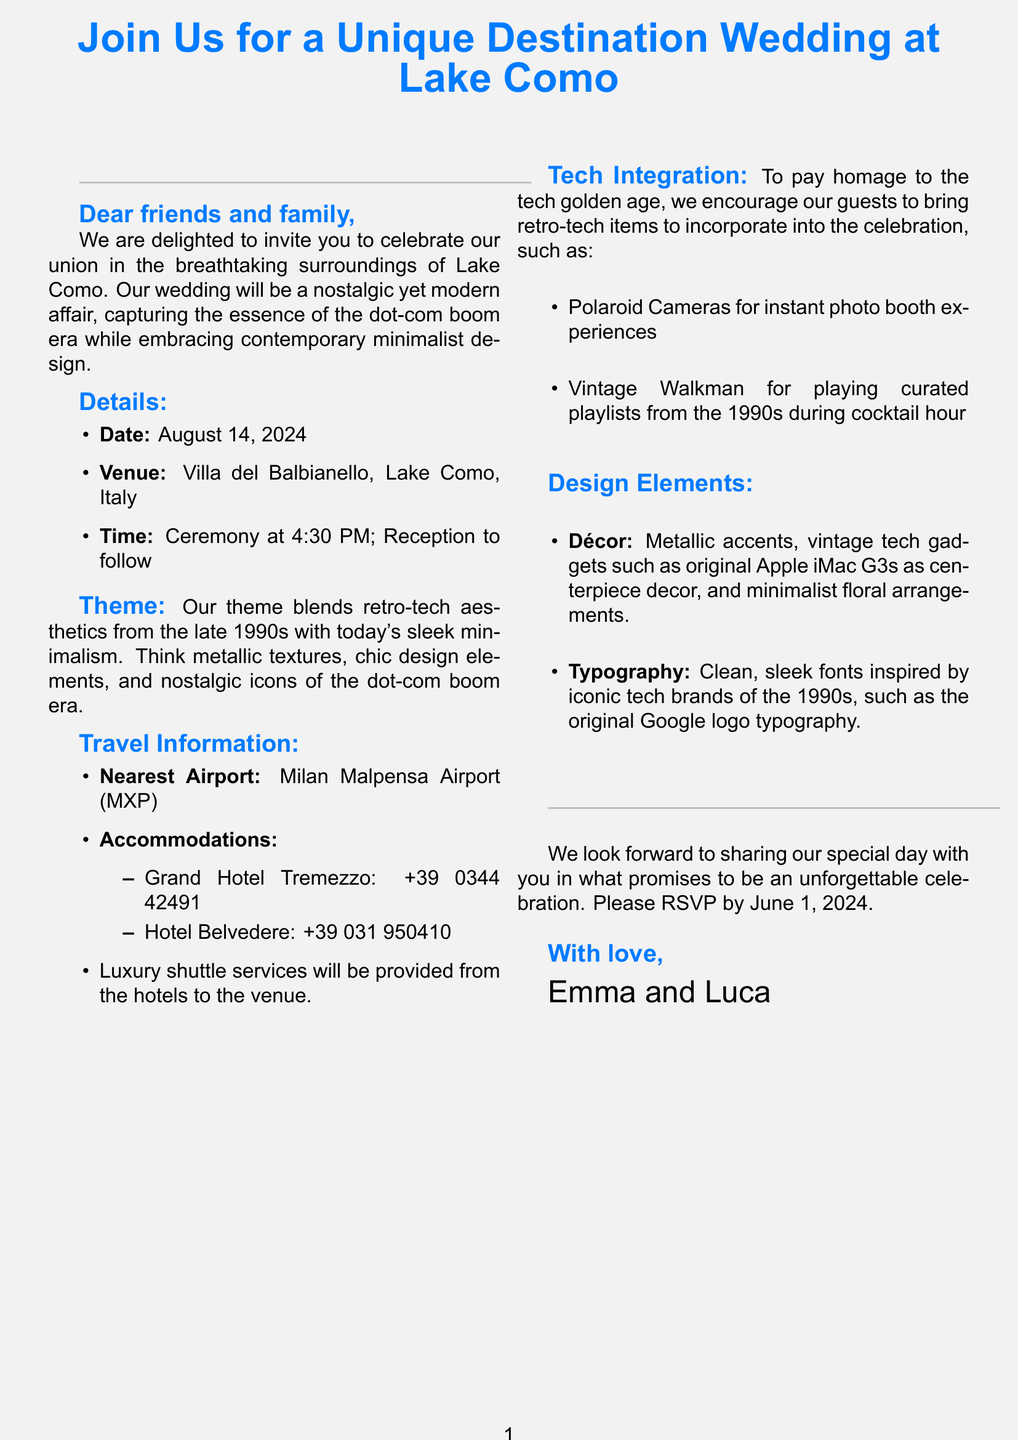What is the date of the wedding? The wedding date is explicitly mentioned in the document.
Answer: August 14, 2024 Where will the wedding ceremony take place? The venue of the wedding is listed in the document.
Answer: Villa del Balbianello, Lake Como, Italy What time is the ceremony scheduled to start? The invitation specifies the start time of the ceremony.
Answer: 4:30 PM Which airport is mentioned as the nearest? The document provides information on travel, including the nearest airport.
Answer: Milan Malpensa Airport (MXP) What type of items guests are encouraged to bring? The document suggests specific items for guests to bring in line with the theme.
Answer: Retro-tech items What theme is being used for the wedding? The invitation describes the theme that blends different aesthetics.
Answer: Retro-tech aesthetics What is the RSVP deadline? The document states when guests need to respond by.
Answer: June 1, 2024 What are the suggested accommodations mentioned? The document provides options for guests to stay during the event.
Answer: Grand Hotel Tremezzo, Hotel Belvedere How is the décor described in the invitation? The document outlines key design elements that will be featured at the wedding.
Answer: Metallic accents, vintage tech gadgets, minimalist floral arrangements 